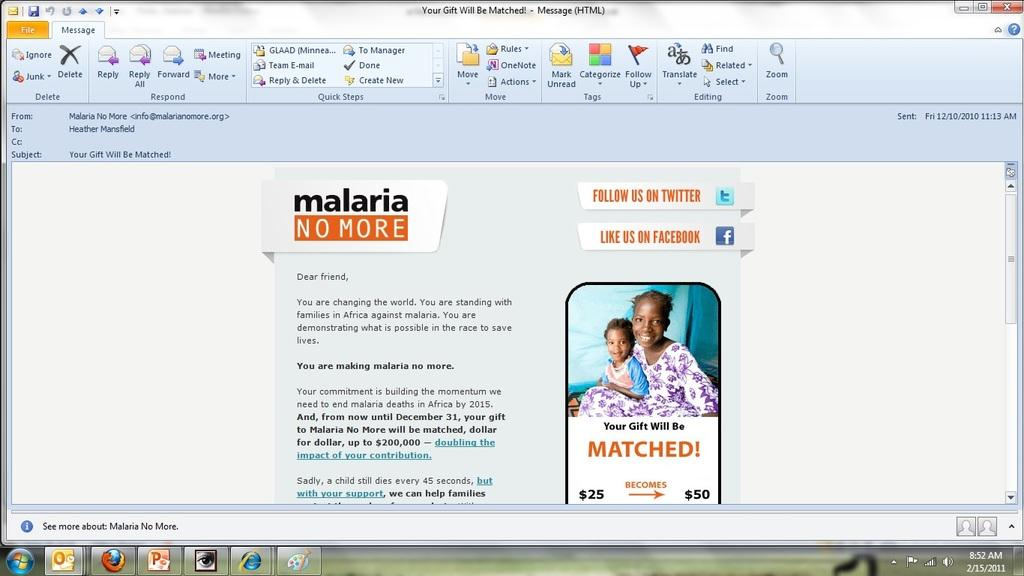<image>
Create a compact narrative representing the image presented. An ad for "Malaria no more" is being created on a computer screen 